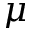Convert formula to latex. <formula><loc_0><loc_0><loc_500><loc_500>\mu</formula> 